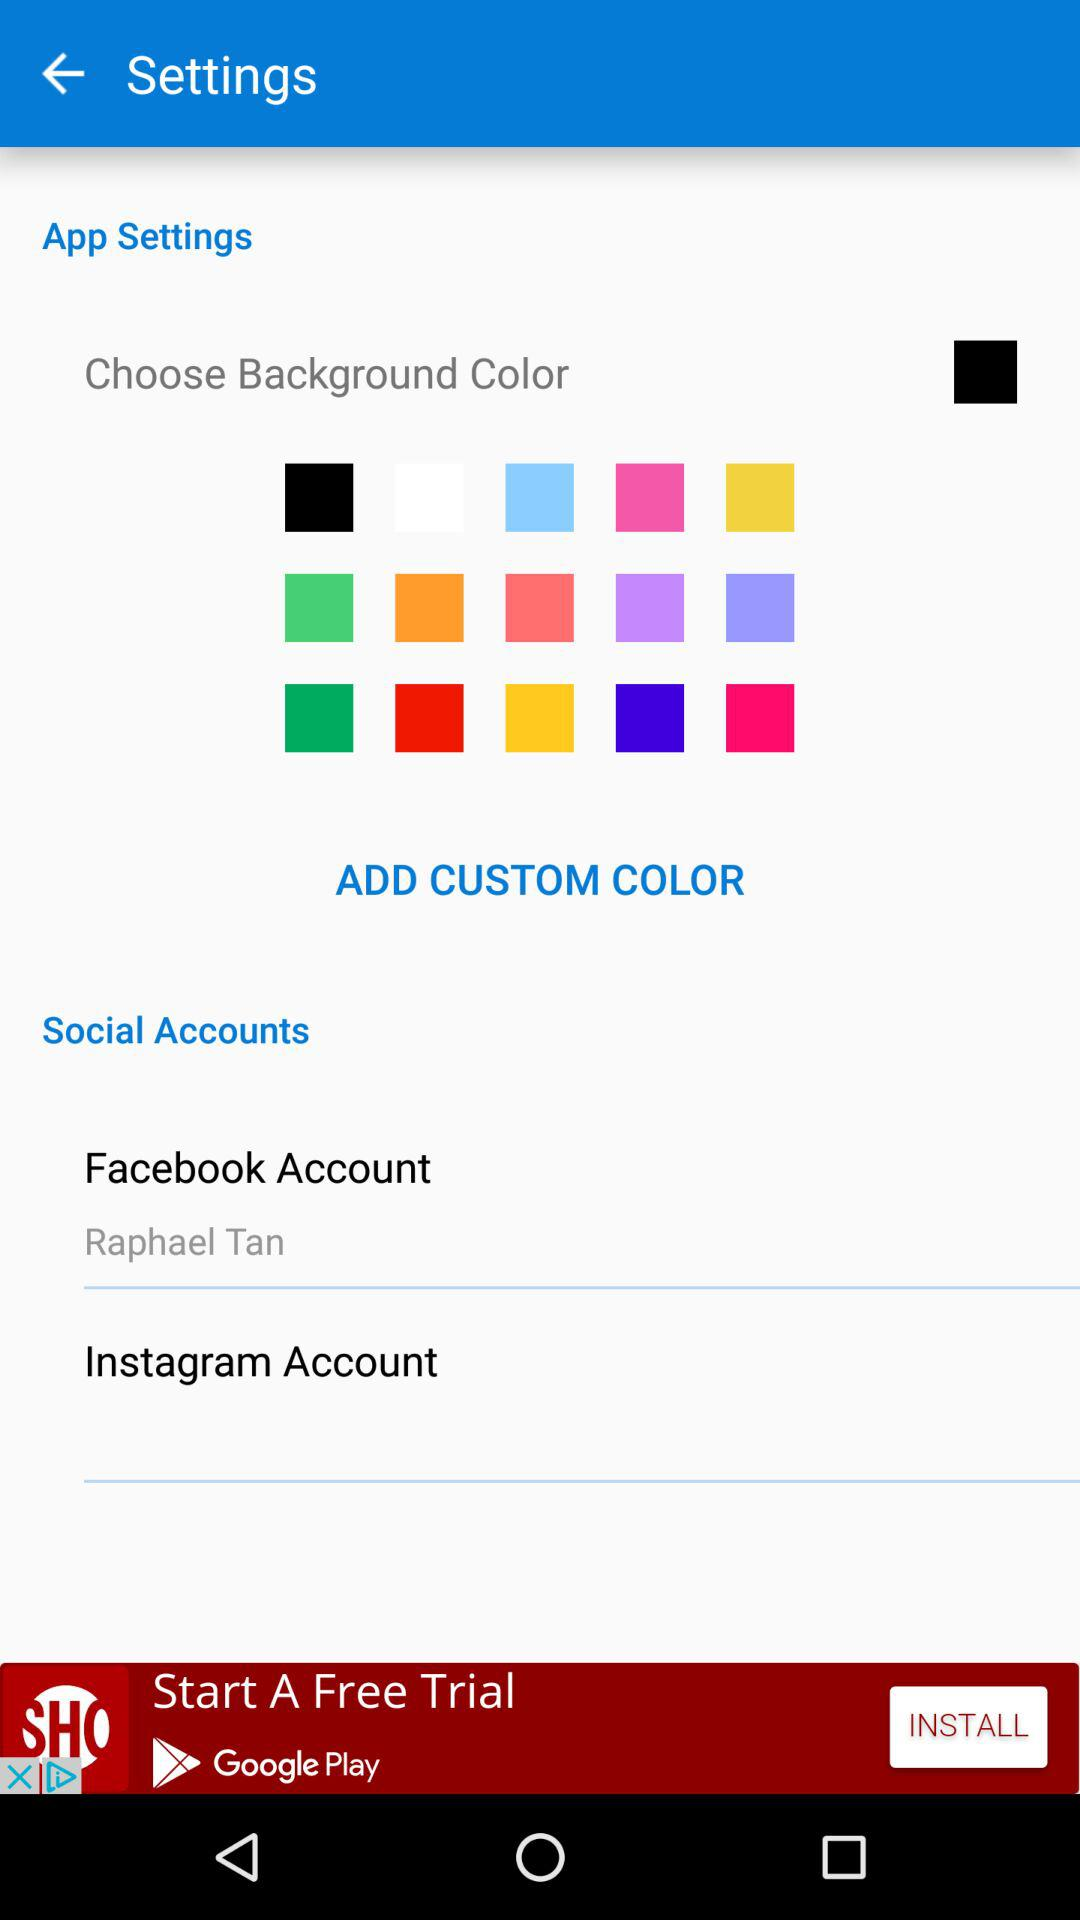What is the Selected Color For Background?
When the provided information is insufficient, respond with <no answer>. <no answer> 